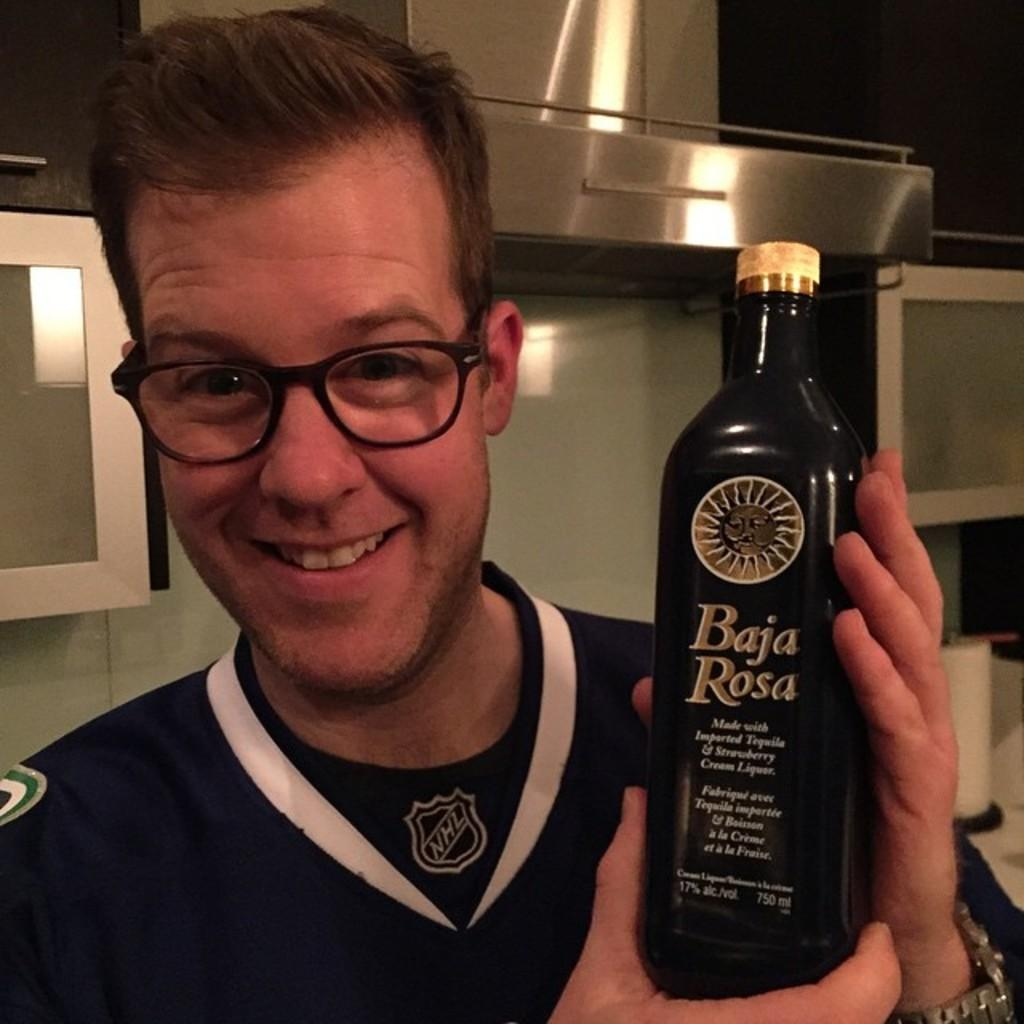What is the man in the image doing? The man is standing and smiling in the image. What is the man holding in the image? The man is holding a bottle in the image. Can you describe the bottle? There is text on the bottle in the image. What can be seen in the background of the image? There might be cupboards and an object in the background of the image. What type of star can be seen in the image? There is no star visible in the image. What type of milk is the man drinking from the bottle? The image does not show the man drinking from the bottle, and there is no mention of milk in the provided facts. 